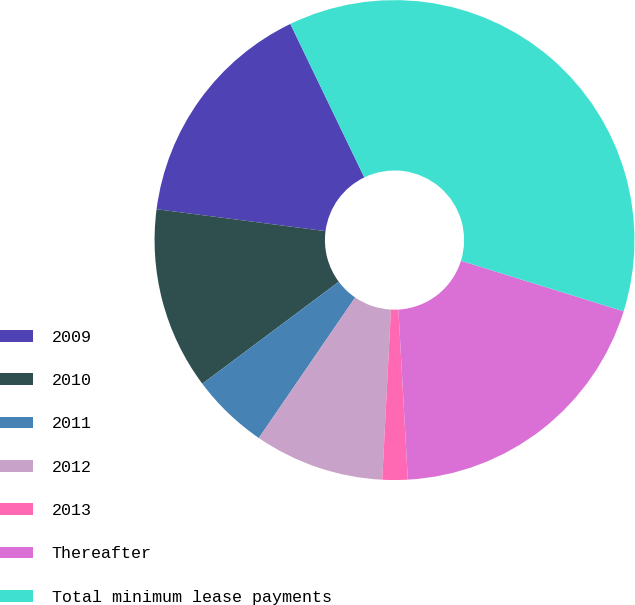Convert chart. <chart><loc_0><loc_0><loc_500><loc_500><pie_chart><fcel>2009<fcel>2010<fcel>2011<fcel>2012<fcel>2013<fcel>Thereafter<fcel>Total minimum lease payments<nl><fcel>15.8%<fcel>12.27%<fcel>5.22%<fcel>8.75%<fcel>1.7%<fcel>19.32%<fcel>36.95%<nl></chart> 